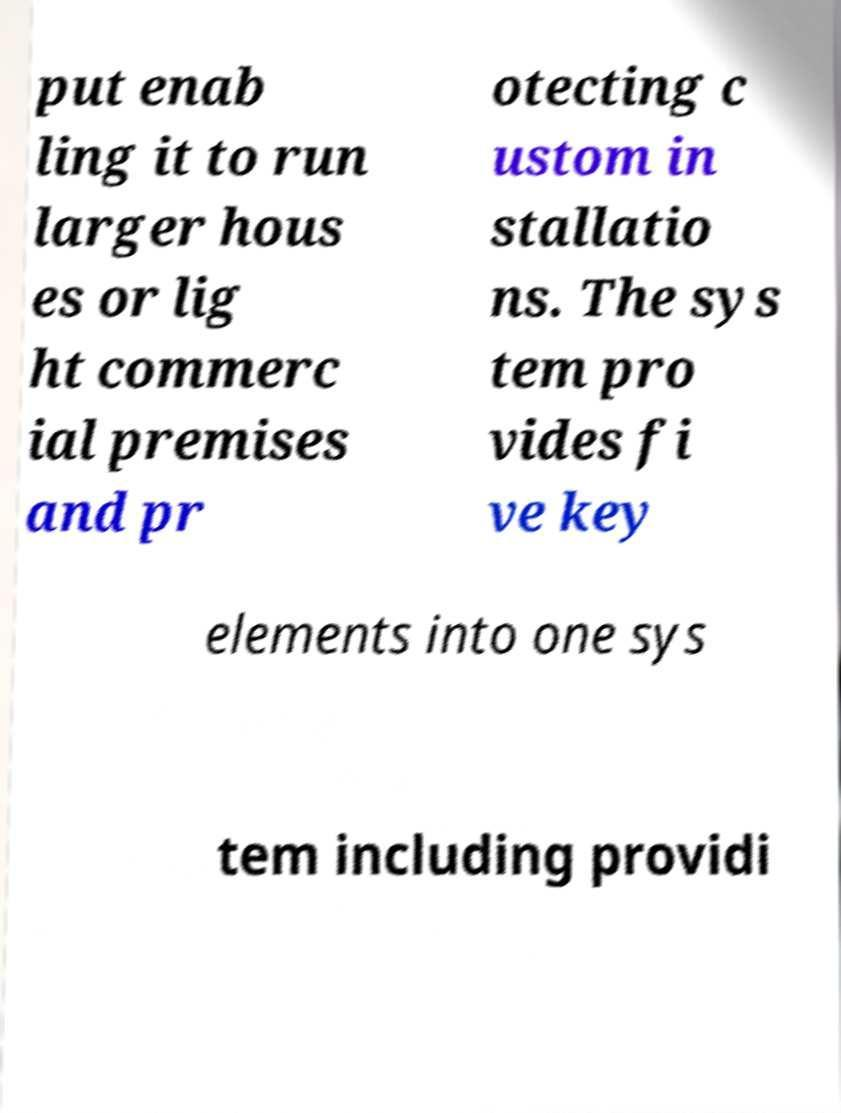There's text embedded in this image that I need extracted. Can you transcribe it verbatim? put enab ling it to run larger hous es or lig ht commerc ial premises and pr otecting c ustom in stallatio ns. The sys tem pro vides fi ve key elements into one sys tem including providi 